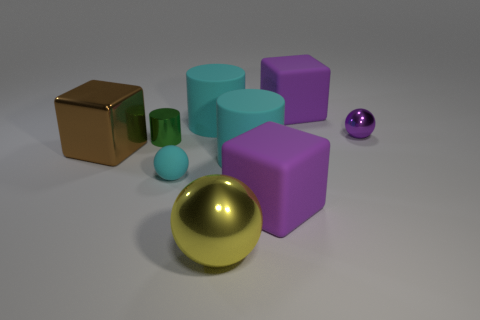Do the small purple thing and the big yellow object have the same shape?
Your response must be concise. Yes. There is a cyan object that is the same shape as the small purple object; what size is it?
Make the answer very short. Small. What size is the yellow thing that is the same material as the brown thing?
Provide a short and direct response. Large. There is a large sphere that is the same material as the green object; what is its color?
Keep it short and to the point. Yellow. What material is the purple thing that is the same shape as the yellow shiny object?
Your answer should be compact. Metal. What is the shape of the tiny rubber thing?
Your answer should be very brief. Sphere. What is the tiny sphere that is in front of the big cyan thing that is right of the cyan cylinder that is behind the green metal object made of?
Keep it short and to the point. Rubber. How many other things are made of the same material as the tiny cyan thing?
Keep it short and to the point. 4. There is a cyan ball in front of the tiny green shiny cylinder; how many tiny cyan rubber spheres are behind it?
Your response must be concise. 0. How many cylinders are either tiny rubber objects or yellow metallic objects?
Make the answer very short. 0. 